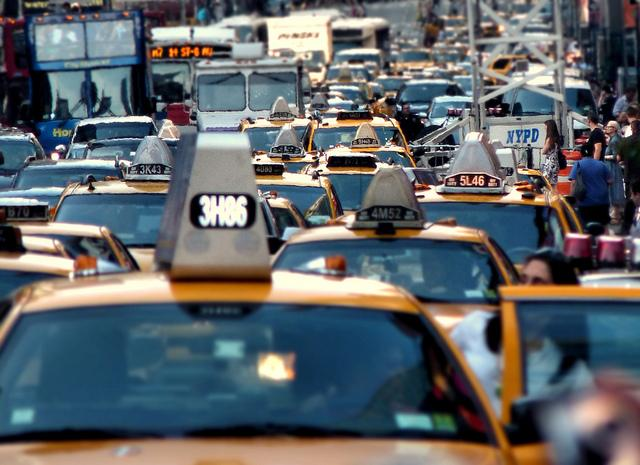What is happening on the road? traffic jam 